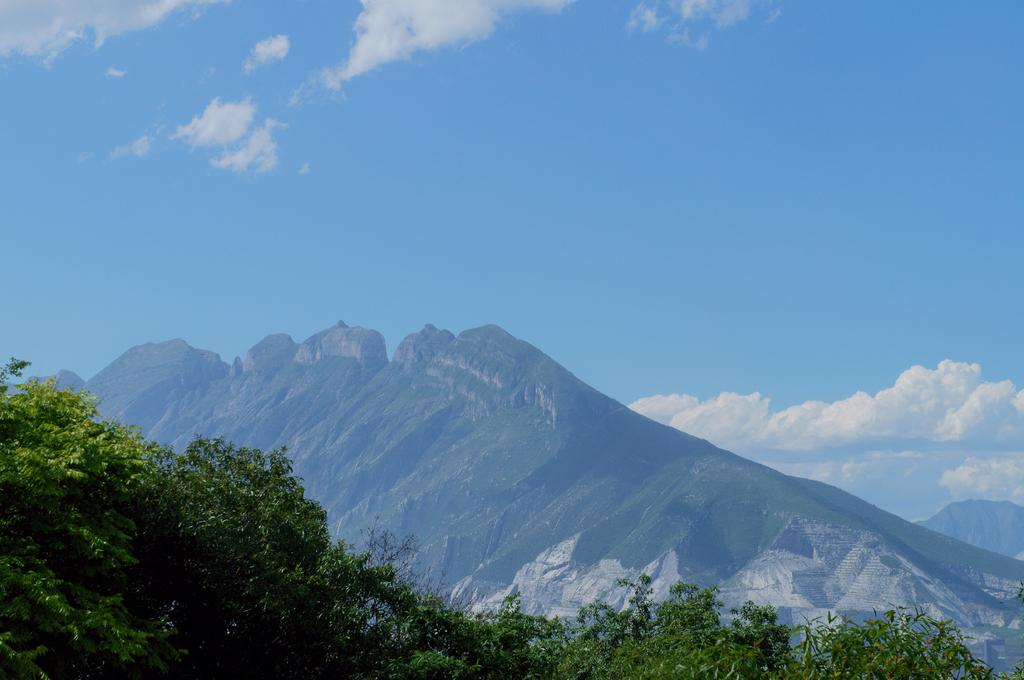What type of natural formation can be seen in the image? There are mountains in the image. What other natural elements are present in the image? There are trees in the image. What can be seen in the background of the image? The sky is visible in the background of the image. What is the condition of the sky in the image? Clouds are present in the sky. Where is the sofa located in the image? There is no sofa present in the image. What type of insect can be seen flying around the trees in the image? There are no insects visible in the image; only mountains, trees, and clouds are present. 